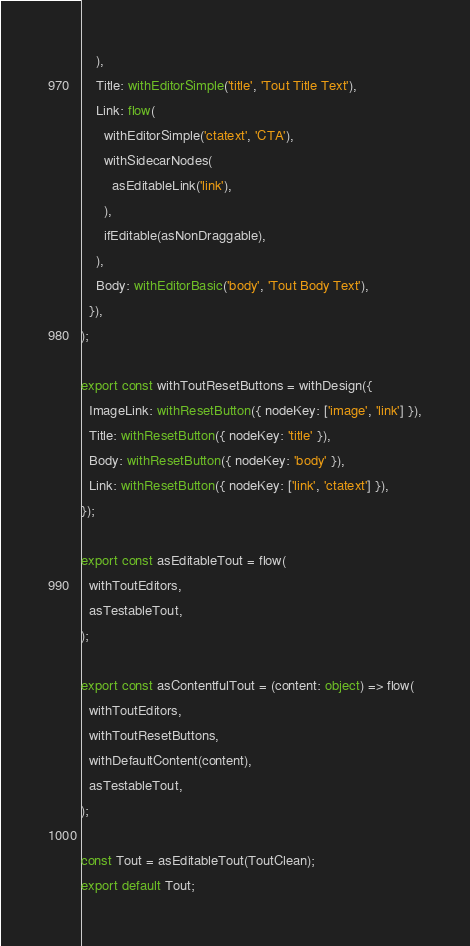Convert code to text. <code><loc_0><loc_0><loc_500><loc_500><_TypeScript_>    ),
    Title: withEditorSimple('title', 'Tout Title Text'),
    Link: flow(
      withEditorSimple('ctatext', 'CTA'),
      withSidecarNodes(
        asEditableLink('link'),
      ),
      ifEditable(asNonDraggable),
    ),
    Body: withEditorBasic('body', 'Tout Body Text'),
  }),
);

export const withToutResetButtons = withDesign({
  ImageLink: withResetButton({ nodeKey: ['image', 'link'] }),
  Title: withResetButton({ nodeKey: 'title' }),
  Body: withResetButton({ nodeKey: 'body' }),
  Link: withResetButton({ nodeKey: ['link', 'ctatext'] }),
});

export const asEditableTout = flow(
  withToutEditors,
  asTestableTout,
);

export const asContentfulTout = (content: object) => flow(
  withToutEditors,
  withToutResetButtons,
  withDefaultContent(content),
  asTestableTout,
);

const Tout = asEditableTout(ToutClean);
export default Tout;
</code> 